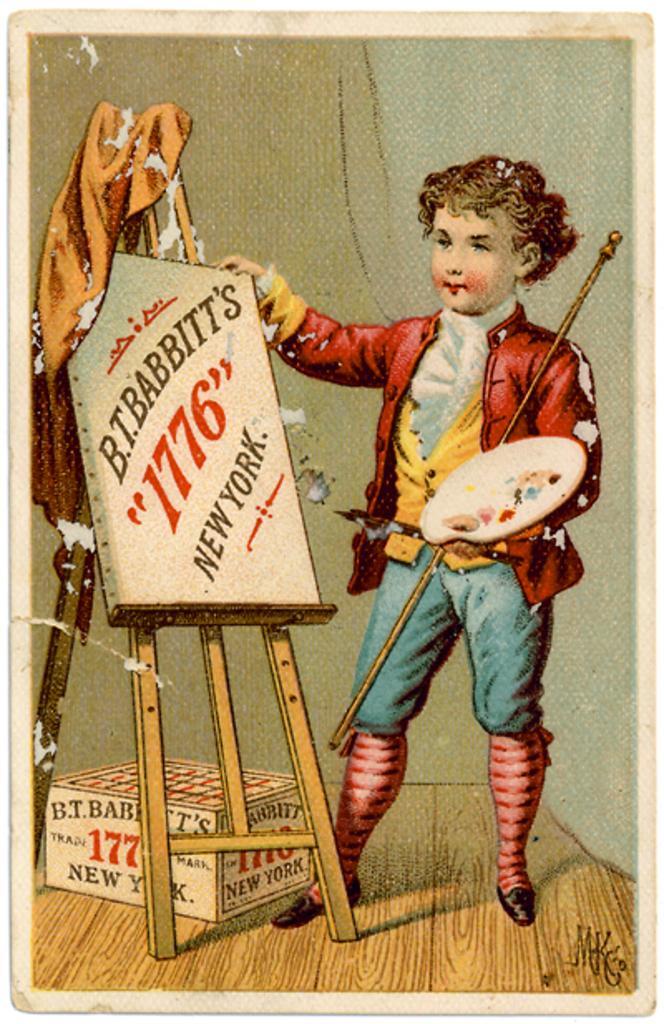Could you give a brief overview of what you see in this image? In this picture we can see a poster, in the poster we can see a boy, he is holding a plate, in front of him we can see a box and a board. 